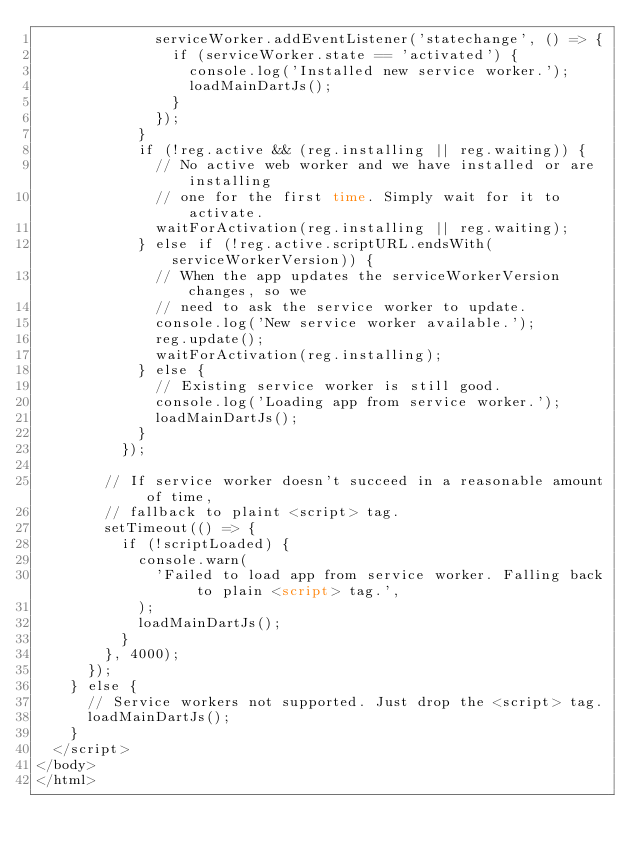<code> <loc_0><loc_0><loc_500><loc_500><_HTML_>              serviceWorker.addEventListener('statechange', () => {
                if (serviceWorker.state == 'activated') {
                  console.log('Installed new service worker.');
                  loadMainDartJs();
                }
              });
            }
            if (!reg.active && (reg.installing || reg.waiting)) {
              // No active web worker and we have installed or are installing
              // one for the first time. Simply wait for it to activate.
              waitForActivation(reg.installing || reg.waiting);
            } else if (!reg.active.scriptURL.endsWith(serviceWorkerVersion)) {
              // When the app updates the serviceWorkerVersion changes, so we
              // need to ask the service worker to update.
              console.log('New service worker available.');
              reg.update();
              waitForActivation(reg.installing);
            } else {
              // Existing service worker is still good.
              console.log('Loading app from service worker.');
              loadMainDartJs();
            }
          });

        // If service worker doesn't succeed in a reasonable amount of time,
        // fallback to plaint <script> tag.
        setTimeout(() => {
          if (!scriptLoaded) {
            console.warn(
              'Failed to load app from service worker. Falling back to plain <script> tag.',
            );
            loadMainDartJs();
          }
        }, 4000);
      });
    } else {
      // Service workers not supported. Just drop the <script> tag.
      loadMainDartJs();
    }
  </script>
</body>
</html>
</code> 